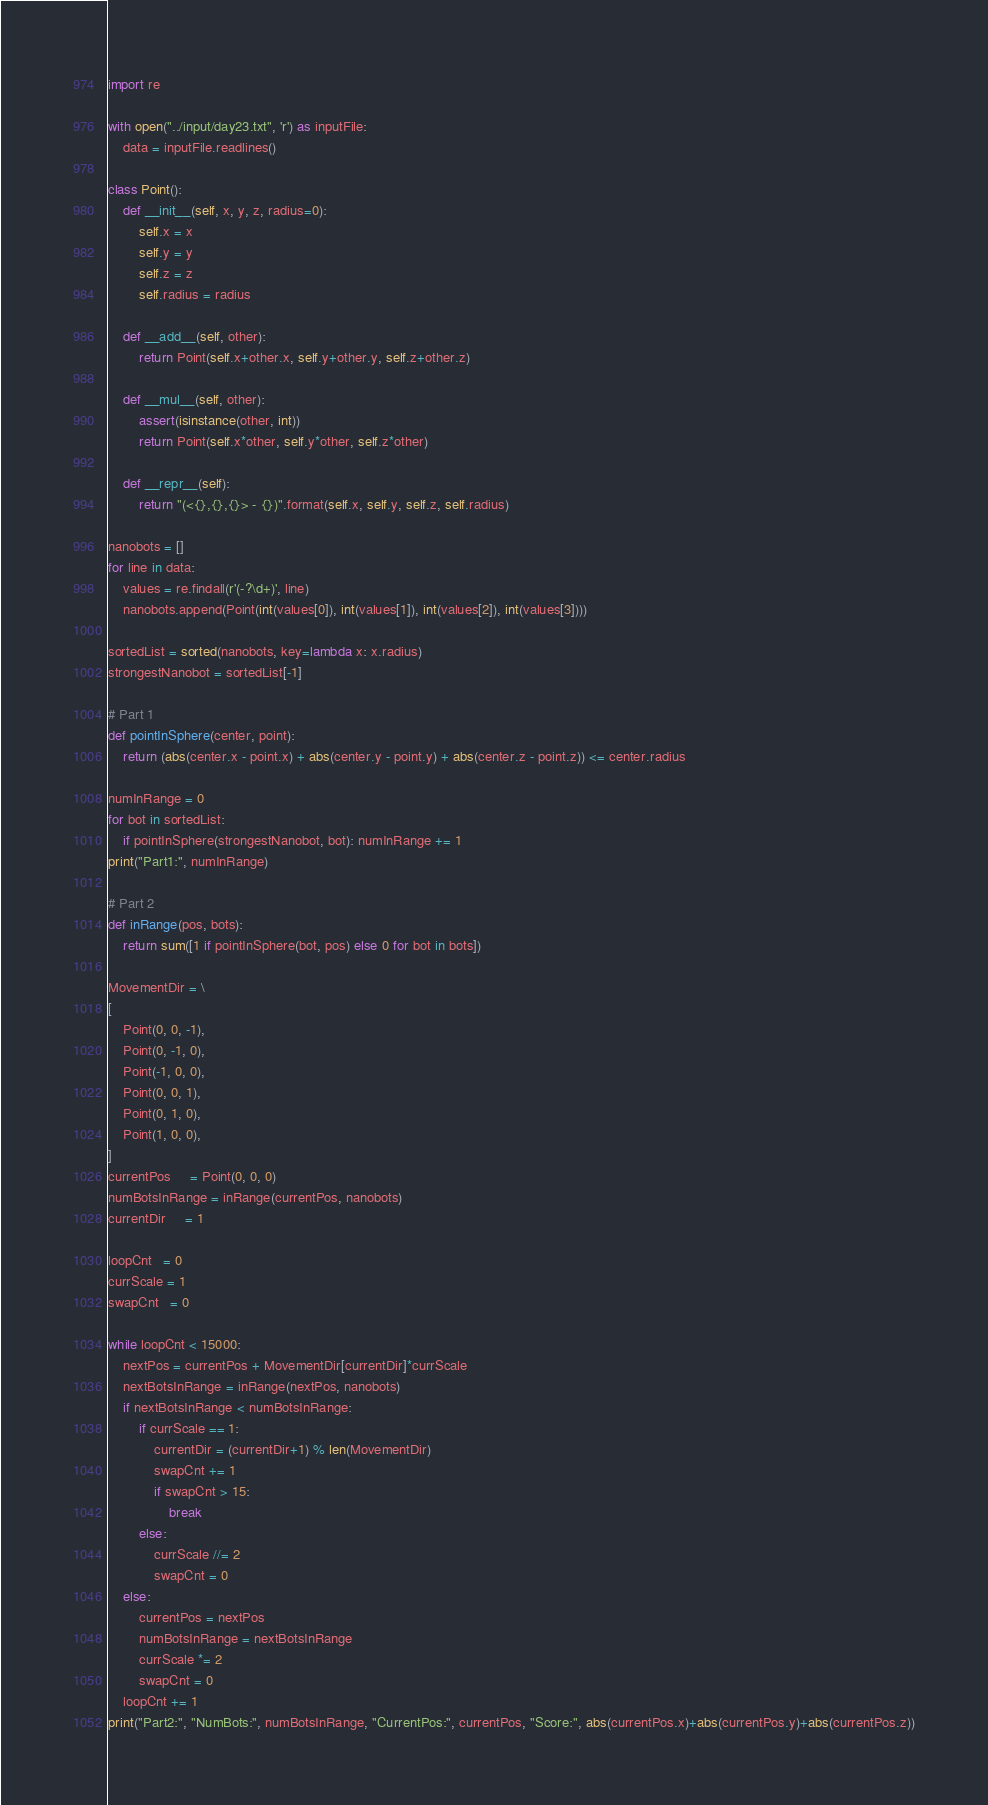Convert code to text. <code><loc_0><loc_0><loc_500><loc_500><_Python_>import re

with open("../input/day23.txt", 'r') as inputFile:
    data = inputFile.readlines()

class Point():
    def __init__(self, x, y, z, radius=0):
        self.x = x
        self.y = y
        self.z = z
        self.radius = radius

    def __add__(self, other):
        return Point(self.x+other.x, self.y+other.y, self.z+other.z)

    def __mul__(self, other):
        assert(isinstance(other, int))
        return Point(self.x*other, self.y*other, self.z*other)

    def __repr__(self):
        return "(<{},{},{}> - {})".format(self.x, self.y, self.z, self.radius)

nanobots = []
for line in data:
    values = re.findall(r'(-?\d+)', line)
    nanobots.append(Point(int(values[0]), int(values[1]), int(values[2]), int(values[3])))

sortedList = sorted(nanobots, key=lambda x: x.radius)
strongestNanobot = sortedList[-1]

# Part 1
def pointInSphere(center, point):
    return (abs(center.x - point.x) + abs(center.y - point.y) + abs(center.z - point.z)) <= center.radius

numInRange = 0
for bot in sortedList:
    if pointInSphere(strongestNanobot, bot): numInRange += 1
print("Part1:", numInRange)

# Part 2
def inRange(pos, bots):
    return sum([1 if pointInSphere(bot, pos) else 0 for bot in bots])

MovementDir = \
[
    Point(0, 0, -1),
    Point(0, -1, 0),
    Point(-1, 0, 0),
    Point(0, 0, 1),
    Point(0, 1, 0),
    Point(1, 0, 0),
]
currentPos     = Point(0, 0, 0)
numBotsInRange = inRange(currentPos, nanobots)
currentDir     = 1

loopCnt   = 0
currScale = 1
swapCnt   = 0

while loopCnt < 15000:
    nextPos = currentPos + MovementDir[currentDir]*currScale
    nextBotsInRange = inRange(nextPos, nanobots)
    if nextBotsInRange < numBotsInRange:
        if currScale == 1:
            currentDir = (currentDir+1) % len(MovementDir)
            swapCnt += 1
            if swapCnt > 15:
                break
        else:
            currScale //= 2
            swapCnt = 0
    else:
        currentPos = nextPos
        numBotsInRange = nextBotsInRange
        currScale *= 2
        swapCnt = 0
    loopCnt += 1
print("Part2:", "NumBots:", numBotsInRange, "CurrentPos:", currentPos, "Score:", abs(currentPos.x)+abs(currentPos.y)+abs(currentPos.z))</code> 